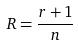Convert formula to latex. <formula><loc_0><loc_0><loc_500><loc_500>R = \frac { r + 1 } { n }</formula> 